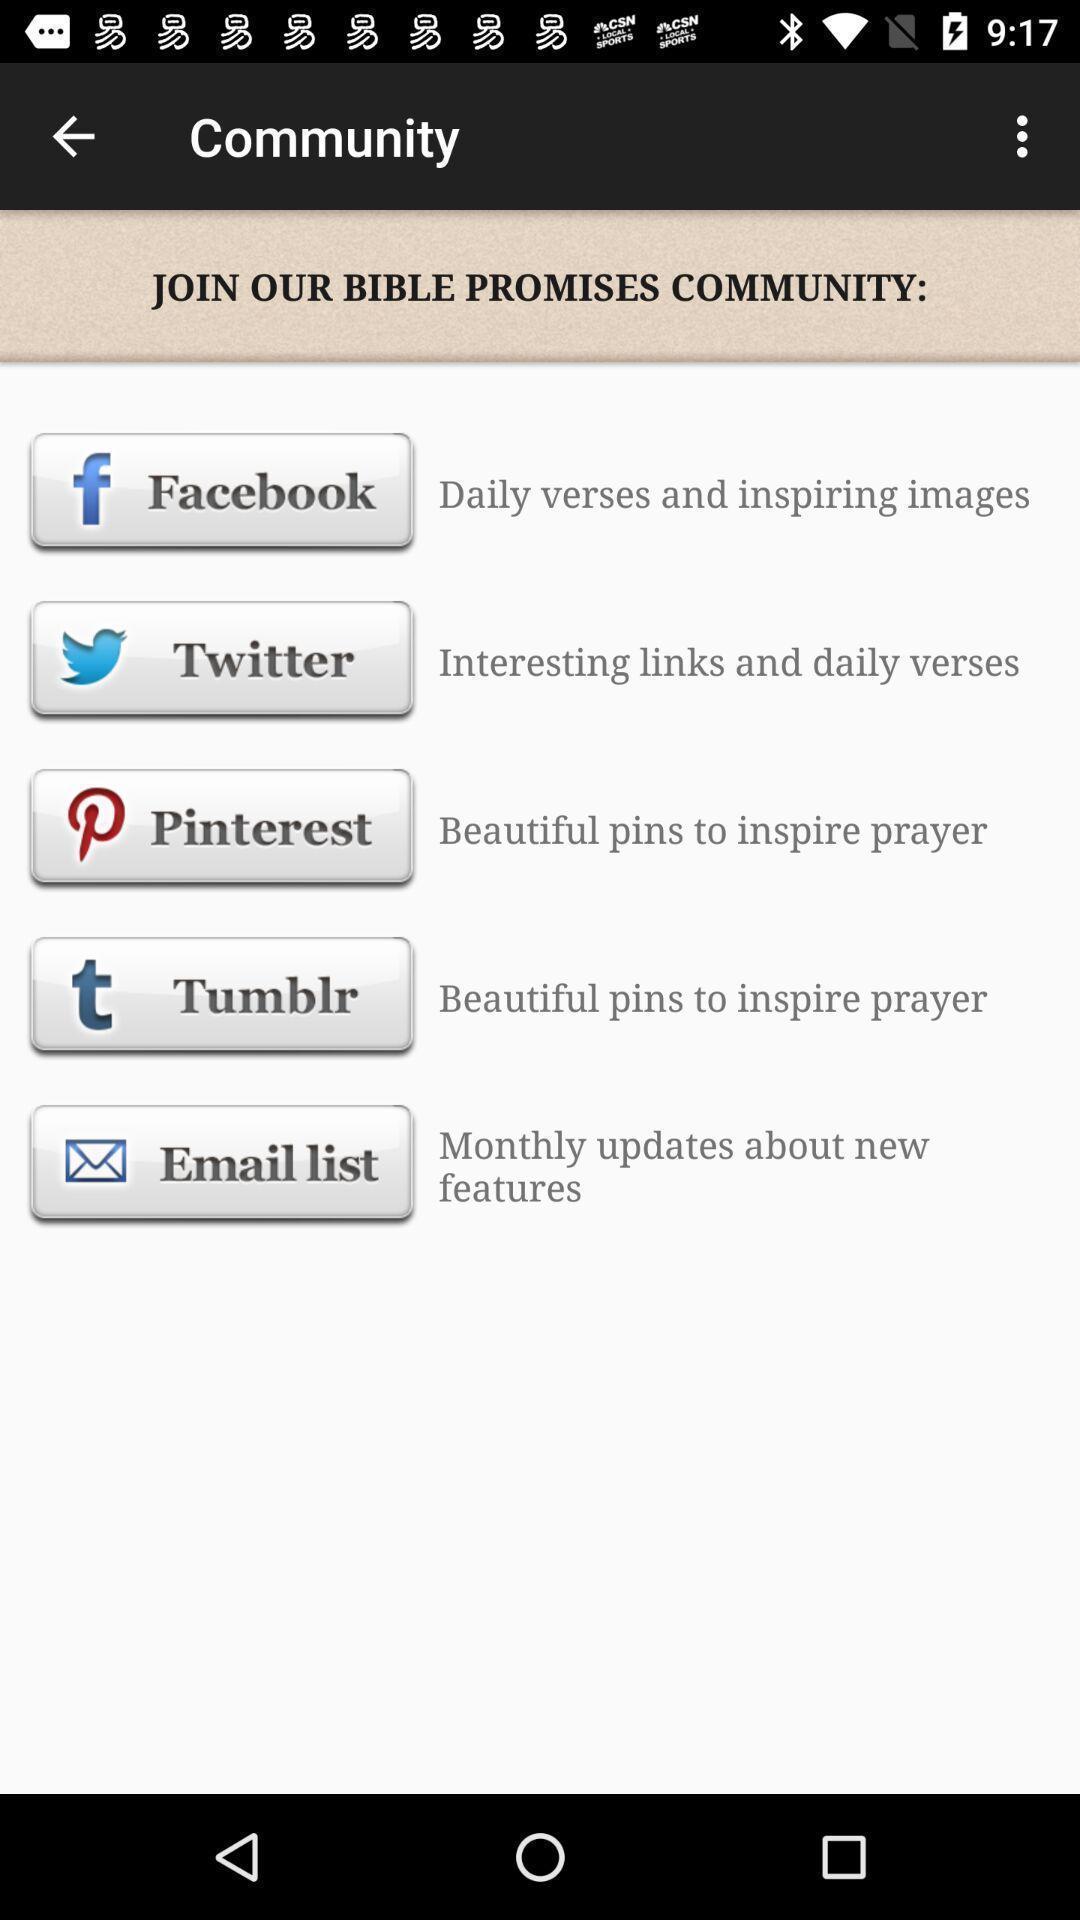Summarize the information in this screenshot. Screen displaying the list of options in community page. 